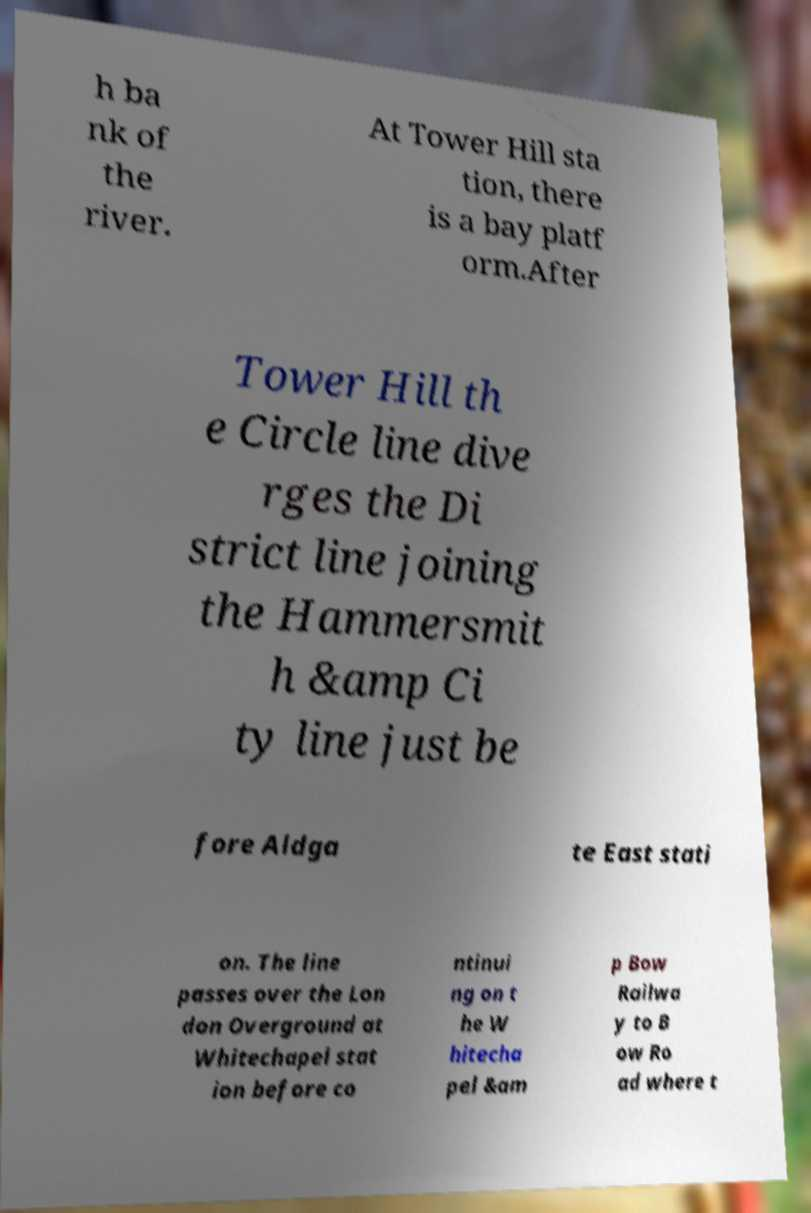I need the written content from this picture converted into text. Can you do that? h ba nk of the river. At Tower Hill sta tion, there is a bay platf orm.After Tower Hill th e Circle line dive rges the Di strict line joining the Hammersmit h &amp Ci ty line just be fore Aldga te East stati on. The line passes over the Lon don Overground at Whitechapel stat ion before co ntinui ng on t he W hitecha pel &am p Bow Railwa y to B ow Ro ad where t 